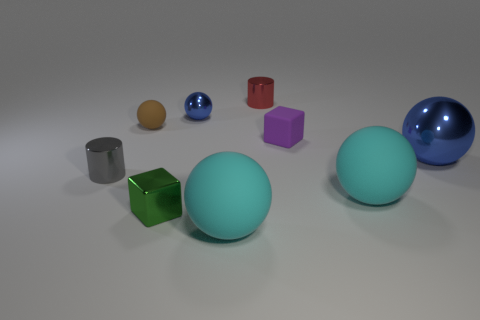Imagine these objects were part of a children's play area, how would you describe their use? In a children's play area, these colorful objects could serve as multisensory educational tools. The large balls could be used for rolling and color identification games, while the smaller shapes might serve as building blocks to improve motor skills and spatial awareness. The differing textures would encourage tactile exploration. The shiny surfaces could intrigue children, prompting questions about light and reflections, thereby weaving in early physics concepts into playtime. 